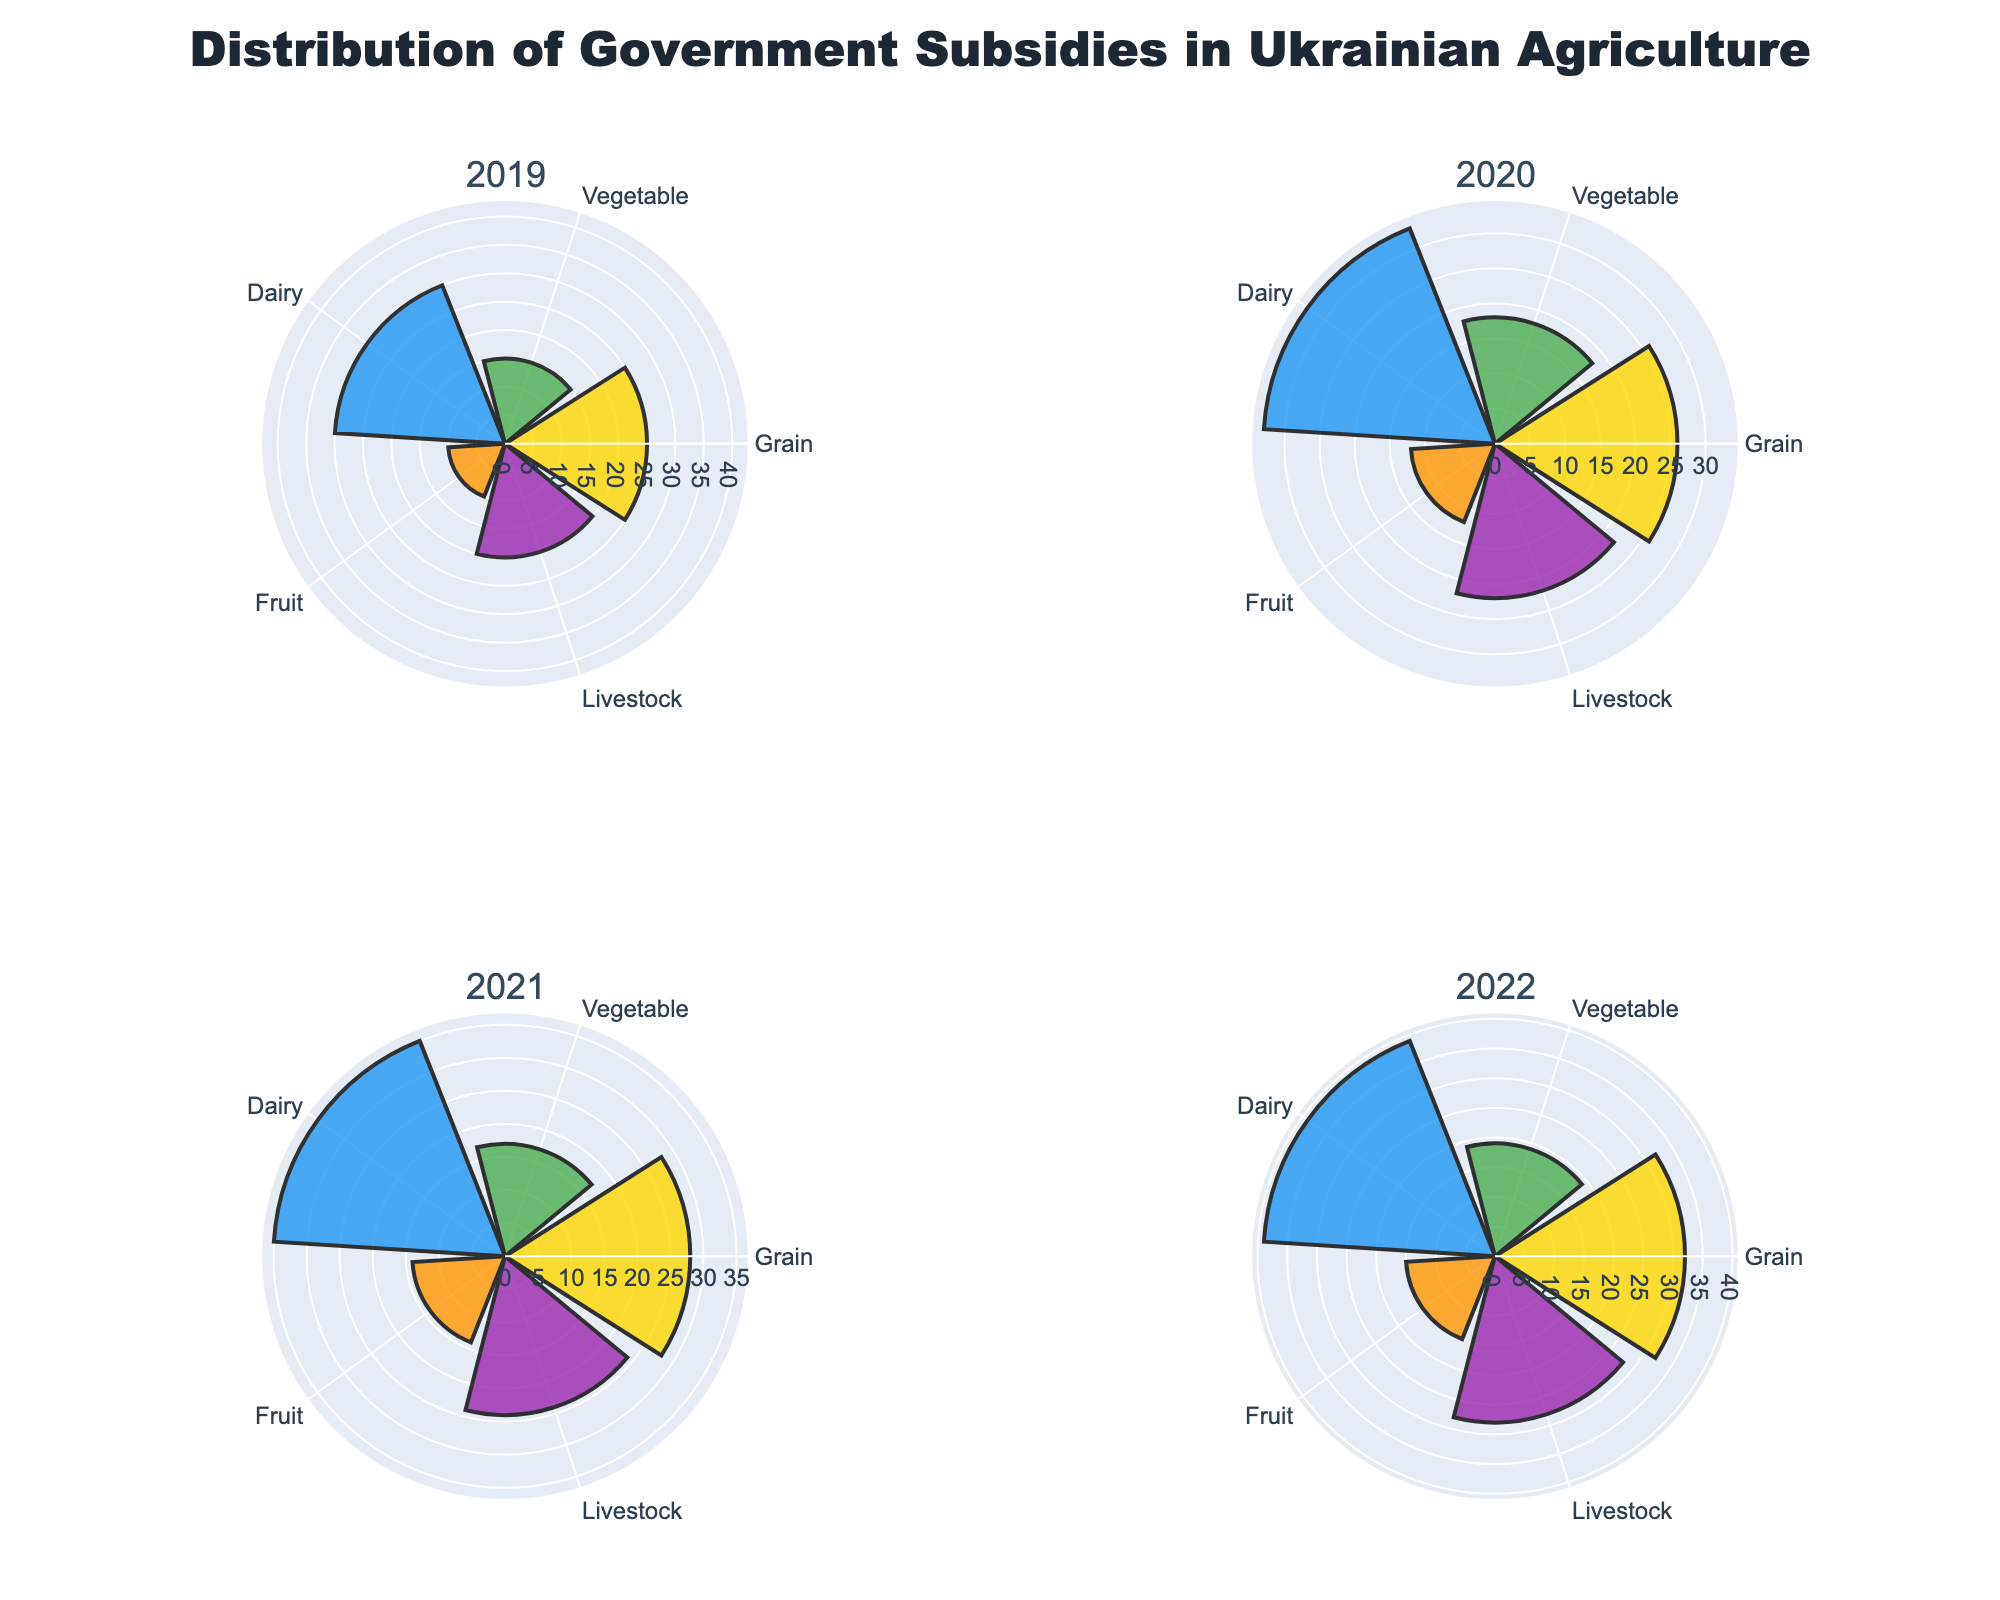What's the title of the figure? The title is centered at the top of the figure and is formatted in a large font size.
Answer: Distribution of Government Subsidies in Ukrainian Agriculture How many subplots are there in the figure? The figure is divided into four subplots, each representing a different year.
Answer: 4 What is the highest subsidy amount given to the Grain sector in any year? In the subplot for 2022, the Grain sector shows a subsidy amount of 32, which is the highest for this sector across all years.
Answer: 32 Which sector received the lowest subsidies consistently over the years? By observing the values across all four subplots, the Fruit sector consistently receives the lowest subsidies each year.
Answer: Fruit What is the average subsidy amount given to the Dairy sector from 2019 to 2022? The subsidies given to the Dairy sector are 30 (2019), 33 (2020), 35 (2021), and 39 (2022). The average is calculated as (30 + 33 + 35 + 39) / 4 = 34.25.
Answer: 34.25 How did the subsidy amount for Livestock change from 2019 to 2022? The subsidy amount for Livestock in 2019 is 20, and it increased to 28 in 2022. The change is calculated as 28 - 20 = 8.
Answer: Increased by 8 Which year shows the highest total subsidy amount across all sectors? Summing the subsidies for each year: 
2019: 25 (Grain) + 15 (Vegetable) + 30 (Dairy) + 10 (Fruit) + 20 (Livestock) = 100
2020: 26 (Grain) + 18 (Vegetable) + 33 (Dairy) + 12 (Fruit) + 22 (Livestock) = 111
2021: 28 (Grain) + 17 (Vegetable) + 35 (Dairy) + 14 (Fruit) + 24 (Livestock) = 118
2022: 32 (Grain) + 19 (Vegetable) + 39 (Dairy) + 15 (Fruit) + 28 (Livestock) = 133
The highest total is in 2022.
Answer: 2022 Which sectors' subsidies increased every year from 2019 to 2022? Observing the trend for each sector over the years:
- Grain: 25, 26, 28, 32 (increased every year)
- Vegetable: 15, 18, 17, 19 (not consistent)
- Dairy: 30, 33, 35, 39 (increased every year)
- Fruit: 10, 12, 14, 15 (increased every year)
- Livestock: 20, 22, 24, 28 (increased every year)
Grain, Dairy, Fruit, and Livestock subsidies increased every year.
Answer: Grain, Dairy, Fruit, Livestock 